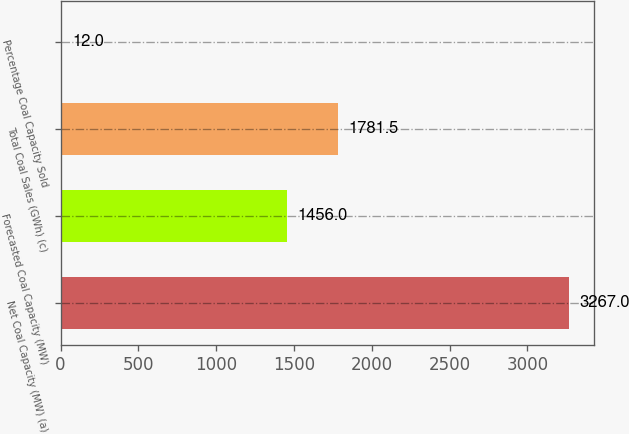Convert chart to OTSL. <chart><loc_0><loc_0><loc_500><loc_500><bar_chart><fcel>Net Coal Capacity (MW) (a)<fcel>Forecasted Coal Capacity (MW)<fcel>Total Coal Sales (GWh) (c)<fcel>Percentage Coal Capacity Sold<nl><fcel>3267<fcel>1456<fcel>1781.5<fcel>12<nl></chart> 